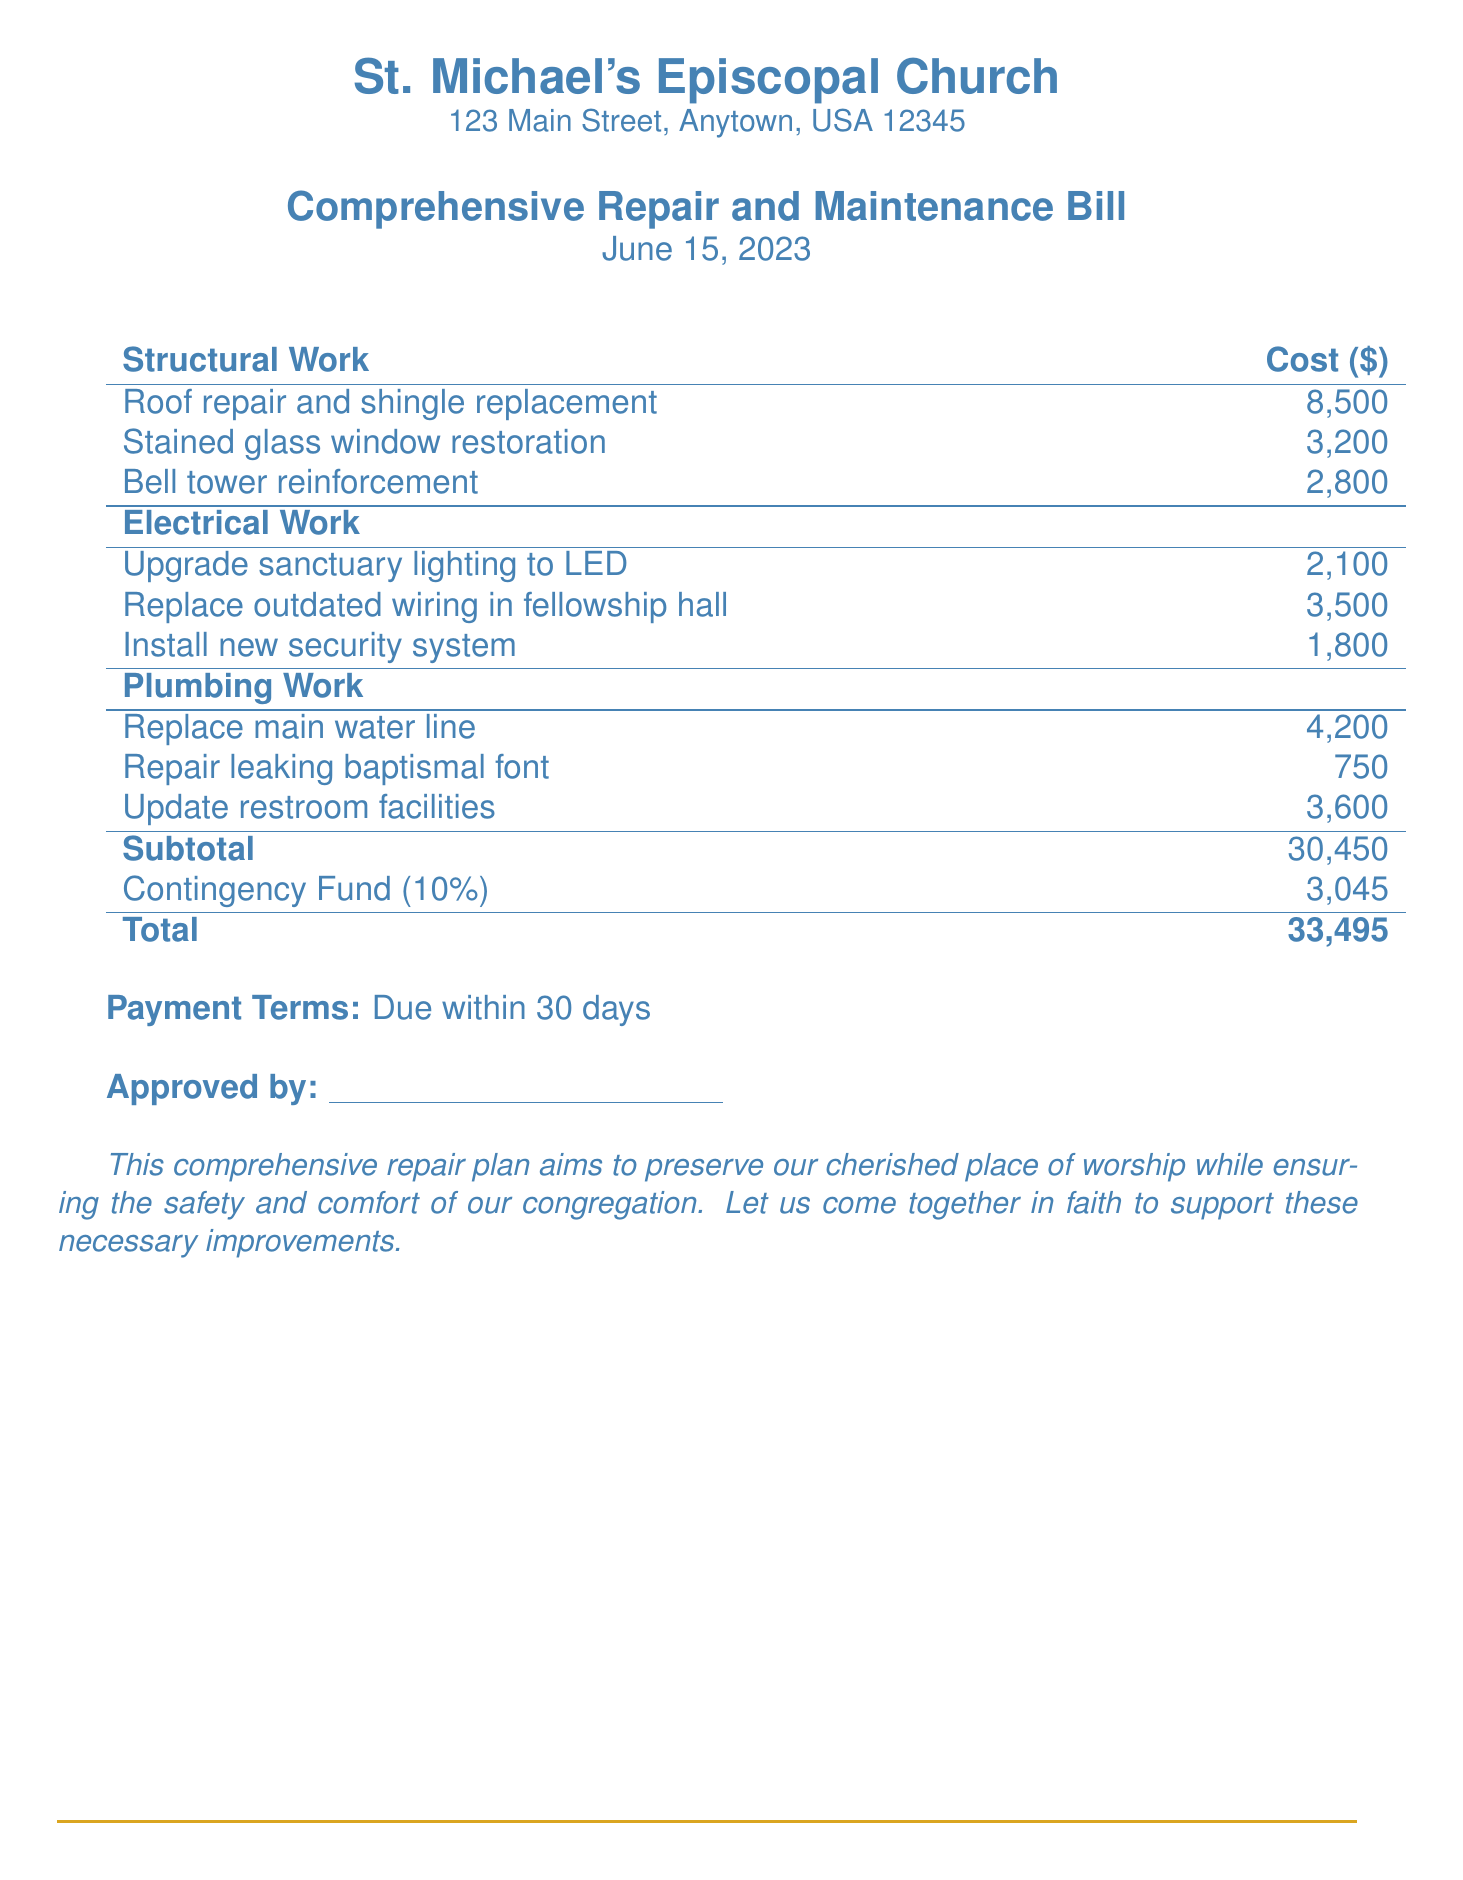What is the date of the bill? The date of the bill is stated at the top of the document as June 15, 2023.
Answer: June 15, 2023 What is the total cost for the repairs? The total cost is listed at the bottom of the document under the total, which is $33,495.
Answer: $33,495 How much is allocated for roof repair? The cost for roof repair, found in the structural work section, is $8,500.
Answer: $8,500 What percentage is the contingency fund based on the subtotal? The contingency fund is noted as being 10% of the subtotal in the document.
Answer: 10% Who approved the bill? There is a line for approval at the bottom, indicating a person is meant to sign it, but no specific name is listed.
Answer: (No name specified) How much is being spent on electrical work? The total for electrical work can be calculated by adding the costs in that section: $2,100 + $3,500 + $1,800 = $7,400.
Answer: $7,400 What line item has the lowest cost? Among the listed costs, the repair of the leaking baptismal font is the lowest at $750.
Answer: $750 What type of work is the most expensive? The most expensive line item is the roof repair, indicated in the structural work section at $8,500.
Answer: Structural Work What is stated as the purpose of the repair plan? The document states that the repair plan aims to preserve the church while ensuring safety and comfort for the congregation.
Answer: Preserve and ensure safety and comfort 